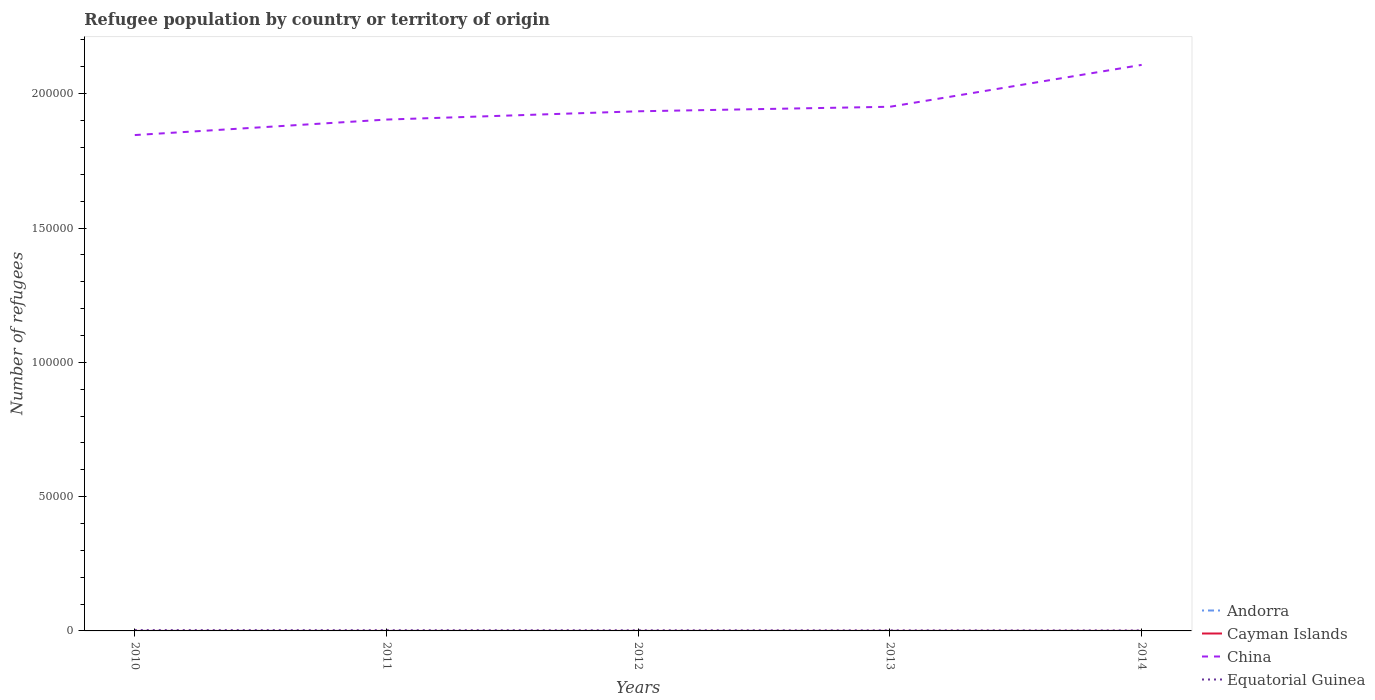How many different coloured lines are there?
Give a very brief answer. 4. Does the line corresponding to Equatorial Guinea intersect with the line corresponding to Cayman Islands?
Provide a succinct answer. No. Is the number of lines equal to the number of legend labels?
Provide a short and direct response. Yes. Across all years, what is the maximum number of refugees in China?
Give a very brief answer. 1.85e+05. In which year was the number of refugees in Cayman Islands maximum?
Your answer should be very brief. 2010. What is the total number of refugees in Andorra in the graph?
Provide a short and direct response. -1. What is the difference between the highest and the second highest number of refugees in Equatorial Guinea?
Provide a succinct answer. 131. What is the difference between the highest and the lowest number of refugees in Equatorial Guinea?
Keep it short and to the point. 2. Is the number of refugees in Andorra strictly greater than the number of refugees in China over the years?
Keep it short and to the point. Yes. How many lines are there?
Make the answer very short. 4. Are the values on the major ticks of Y-axis written in scientific E-notation?
Give a very brief answer. No. Does the graph contain any zero values?
Provide a succinct answer. No. Where does the legend appear in the graph?
Offer a terse response. Bottom right. What is the title of the graph?
Make the answer very short. Refugee population by country or territory of origin. What is the label or title of the X-axis?
Ensure brevity in your answer.  Years. What is the label or title of the Y-axis?
Provide a succinct answer. Number of refugees. What is the Number of refugees in Andorra in 2010?
Provide a succinct answer. 6. What is the Number of refugees of Cayman Islands in 2010?
Your response must be concise. 1. What is the Number of refugees of China in 2010?
Offer a very short reply. 1.85e+05. What is the Number of refugees of Equatorial Guinea in 2010?
Ensure brevity in your answer.  305. What is the Number of refugees in Andorra in 2011?
Ensure brevity in your answer.  6. What is the Number of refugees in Cayman Islands in 2011?
Offer a terse response. 1. What is the Number of refugees in China in 2011?
Make the answer very short. 1.90e+05. What is the Number of refugees of Equatorial Guinea in 2011?
Keep it short and to the point. 258. What is the Number of refugees of Andorra in 2012?
Your answer should be very brief. 7. What is the Number of refugees of China in 2012?
Make the answer very short. 1.93e+05. What is the Number of refugees in Equatorial Guinea in 2012?
Make the answer very short. 228. What is the Number of refugees of Cayman Islands in 2013?
Keep it short and to the point. 6. What is the Number of refugees of China in 2013?
Provide a succinct answer. 1.95e+05. What is the Number of refugees in Andorra in 2014?
Give a very brief answer. 7. What is the Number of refugees in China in 2014?
Make the answer very short. 2.11e+05. What is the Number of refugees of Equatorial Guinea in 2014?
Your answer should be compact. 174. Across all years, what is the maximum Number of refugees of China?
Ensure brevity in your answer.  2.11e+05. Across all years, what is the maximum Number of refugees of Equatorial Guinea?
Offer a terse response. 305. Across all years, what is the minimum Number of refugees in Andorra?
Provide a succinct answer. 5. Across all years, what is the minimum Number of refugees of China?
Provide a short and direct response. 1.85e+05. Across all years, what is the minimum Number of refugees of Equatorial Guinea?
Your answer should be compact. 174. What is the total Number of refugees of Andorra in the graph?
Offer a terse response. 31. What is the total Number of refugees in China in the graph?
Keep it short and to the point. 9.74e+05. What is the total Number of refugees in Equatorial Guinea in the graph?
Make the answer very short. 1165. What is the difference between the Number of refugees of Andorra in 2010 and that in 2011?
Keep it short and to the point. 0. What is the difference between the Number of refugees of Cayman Islands in 2010 and that in 2011?
Provide a succinct answer. 0. What is the difference between the Number of refugees of China in 2010 and that in 2011?
Your answer should be very brief. -5767. What is the difference between the Number of refugees in Andorra in 2010 and that in 2012?
Provide a short and direct response. -1. What is the difference between the Number of refugees in China in 2010 and that in 2012?
Your answer should be compact. -8851. What is the difference between the Number of refugees of Equatorial Guinea in 2010 and that in 2012?
Make the answer very short. 77. What is the difference between the Number of refugees in Cayman Islands in 2010 and that in 2013?
Make the answer very short. -5. What is the difference between the Number of refugees in China in 2010 and that in 2013?
Provide a succinct answer. -1.05e+04. What is the difference between the Number of refugees of Equatorial Guinea in 2010 and that in 2013?
Your answer should be compact. 105. What is the difference between the Number of refugees in Andorra in 2010 and that in 2014?
Your answer should be compact. -1. What is the difference between the Number of refugees of Cayman Islands in 2010 and that in 2014?
Your answer should be compact. -5. What is the difference between the Number of refugees in China in 2010 and that in 2014?
Your response must be concise. -2.61e+04. What is the difference between the Number of refugees of Equatorial Guinea in 2010 and that in 2014?
Make the answer very short. 131. What is the difference between the Number of refugees of Cayman Islands in 2011 and that in 2012?
Your response must be concise. 0. What is the difference between the Number of refugees in China in 2011 and that in 2012?
Make the answer very short. -3084. What is the difference between the Number of refugees in Andorra in 2011 and that in 2013?
Your answer should be compact. 1. What is the difference between the Number of refugees of China in 2011 and that in 2013?
Your response must be concise. -4768. What is the difference between the Number of refugees of Equatorial Guinea in 2011 and that in 2013?
Offer a very short reply. 58. What is the difference between the Number of refugees of Cayman Islands in 2011 and that in 2014?
Ensure brevity in your answer.  -5. What is the difference between the Number of refugees in China in 2011 and that in 2014?
Offer a very short reply. -2.04e+04. What is the difference between the Number of refugees in Cayman Islands in 2012 and that in 2013?
Offer a very short reply. -5. What is the difference between the Number of refugees in China in 2012 and that in 2013?
Your answer should be very brief. -1684. What is the difference between the Number of refugees of Equatorial Guinea in 2012 and that in 2013?
Your response must be concise. 28. What is the difference between the Number of refugees of China in 2012 and that in 2014?
Offer a terse response. -1.73e+04. What is the difference between the Number of refugees of Equatorial Guinea in 2012 and that in 2014?
Provide a succinct answer. 54. What is the difference between the Number of refugees in Andorra in 2013 and that in 2014?
Your answer should be very brief. -2. What is the difference between the Number of refugees in China in 2013 and that in 2014?
Keep it short and to the point. -1.56e+04. What is the difference between the Number of refugees of Andorra in 2010 and the Number of refugees of China in 2011?
Give a very brief answer. -1.90e+05. What is the difference between the Number of refugees in Andorra in 2010 and the Number of refugees in Equatorial Guinea in 2011?
Offer a terse response. -252. What is the difference between the Number of refugees in Cayman Islands in 2010 and the Number of refugees in China in 2011?
Provide a short and direct response. -1.90e+05. What is the difference between the Number of refugees of Cayman Islands in 2010 and the Number of refugees of Equatorial Guinea in 2011?
Your answer should be compact. -257. What is the difference between the Number of refugees of China in 2010 and the Number of refugees of Equatorial Guinea in 2011?
Your response must be concise. 1.84e+05. What is the difference between the Number of refugees in Andorra in 2010 and the Number of refugees in China in 2012?
Offer a terse response. -1.93e+05. What is the difference between the Number of refugees of Andorra in 2010 and the Number of refugees of Equatorial Guinea in 2012?
Ensure brevity in your answer.  -222. What is the difference between the Number of refugees in Cayman Islands in 2010 and the Number of refugees in China in 2012?
Provide a short and direct response. -1.93e+05. What is the difference between the Number of refugees of Cayman Islands in 2010 and the Number of refugees of Equatorial Guinea in 2012?
Make the answer very short. -227. What is the difference between the Number of refugees in China in 2010 and the Number of refugees in Equatorial Guinea in 2012?
Keep it short and to the point. 1.84e+05. What is the difference between the Number of refugees of Andorra in 2010 and the Number of refugees of China in 2013?
Offer a terse response. -1.95e+05. What is the difference between the Number of refugees of Andorra in 2010 and the Number of refugees of Equatorial Guinea in 2013?
Make the answer very short. -194. What is the difference between the Number of refugees in Cayman Islands in 2010 and the Number of refugees in China in 2013?
Provide a short and direct response. -1.95e+05. What is the difference between the Number of refugees of Cayman Islands in 2010 and the Number of refugees of Equatorial Guinea in 2013?
Offer a very short reply. -199. What is the difference between the Number of refugees in China in 2010 and the Number of refugees in Equatorial Guinea in 2013?
Keep it short and to the point. 1.84e+05. What is the difference between the Number of refugees in Andorra in 2010 and the Number of refugees in Cayman Islands in 2014?
Give a very brief answer. 0. What is the difference between the Number of refugees in Andorra in 2010 and the Number of refugees in China in 2014?
Your response must be concise. -2.11e+05. What is the difference between the Number of refugees in Andorra in 2010 and the Number of refugees in Equatorial Guinea in 2014?
Keep it short and to the point. -168. What is the difference between the Number of refugees of Cayman Islands in 2010 and the Number of refugees of China in 2014?
Your response must be concise. -2.11e+05. What is the difference between the Number of refugees of Cayman Islands in 2010 and the Number of refugees of Equatorial Guinea in 2014?
Your response must be concise. -173. What is the difference between the Number of refugees of China in 2010 and the Number of refugees of Equatorial Guinea in 2014?
Provide a short and direct response. 1.84e+05. What is the difference between the Number of refugees of Andorra in 2011 and the Number of refugees of China in 2012?
Your response must be concise. -1.93e+05. What is the difference between the Number of refugees in Andorra in 2011 and the Number of refugees in Equatorial Guinea in 2012?
Make the answer very short. -222. What is the difference between the Number of refugees in Cayman Islands in 2011 and the Number of refugees in China in 2012?
Give a very brief answer. -1.93e+05. What is the difference between the Number of refugees in Cayman Islands in 2011 and the Number of refugees in Equatorial Guinea in 2012?
Offer a very short reply. -227. What is the difference between the Number of refugees of China in 2011 and the Number of refugees of Equatorial Guinea in 2012?
Make the answer very short. 1.90e+05. What is the difference between the Number of refugees of Andorra in 2011 and the Number of refugees of China in 2013?
Keep it short and to the point. -1.95e+05. What is the difference between the Number of refugees of Andorra in 2011 and the Number of refugees of Equatorial Guinea in 2013?
Offer a very short reply. -194. What is the difference between the Number of refugees of Cayman Islands in 2011 and the Number of refugees of China in 2013?
Your answer should be very brief. -1.95e+05. What is the difference between the Number of refugees of Cayman Islands in 2011 and the Number of refugees of Equatorial Guinea in 2013?
Offer a very short reply. -199. What is the difference between the Number of refugees in China in 2011 and the Number of refugees in Equatorial Guinea in 2013?
Offer a very short reply. 1.90e+05. What is the difference between the Number of refugees in Andorra in 2011 and the Number of refugees in China in 2014?
Ensure brevity in your answer.  -2.11e+05. What is the difference between the Number of refugees of Andorra in 2011 and the Number of refugees of Equatorial Guinea in 2014?
Ensure brevity in your answer.  -168. What is the difference between the Number of refugees in Cayman Islands in 2011 and the Number of refugees in China in 2014?
Give a very brief answer. -2.11e+05. What is the difference between the Number of refugees in Cayman Islands in 2011 and the Number of refugees in Equatorial Guinea in 2014?
Your answer should be very brief. -173. What is the difference between the Number of refugees in China in 2011 and the Number of refugees in Equatorial Guinea in 2014?
Ensure brevity in your answer.  1.90e+05. What is the difference between the Number of refugees of Andorra in 2012 and the Number of refugees of China in 2013?
Ensure brevity in your answer.  -1.95e+05. What is the difference between the Number of refugees of Andorra in 2012 and the Number of refugees of Equatorial Guinea in 2013?
Provide a succinct answer. -193. What is the difference between the Number of refugees of Cayman Islands in 2012 and the Number of refugees of China in 2013?
Provide a succinct answer. -1.95e+05. What is the difference between the Number of refugees in Cayman Islands in 2012 and the Number of refugees in Equatorial Guinea in 2013?
Offer a very short reply. -199. What is the difference between the Number of refugees of China in 2012 and the Number of refugees of Equatorial Guinea in 2013?
Ensure brevity in your answer.  1.93e+05. What is the difference between the Number of refugees of Andorra in 2012 and the Number of refugees of Cayman Islands in 2014?
Offer a terse response. 1. What is the difference between the Number of refugees in Andorra in 2012 and the Number of refugees in China in 2014?
Give a very brief answer. -2.11e+05. What is the difference between the Number of refugees of Andorra in 2012 and the Number of refugees of Equatorial Guinea in 2014?
Offer a terse response. -167. What is the difference between the Number of refugees of Cayman Islands in 2012 and the Number of refugees of China in 2014?
Your answer should be very brief. -2.11e+05. What is the difference between the Number of refugees in Cayman Islands in 2012 and the Number of refugees in Equatorial Guinea in 2014?
Offer a terse response. -173. What is the difference between the Number of refugees of China in 2012 and the Number of refugees of Equatorial Guinea in 2014?
Ensure brevity in your answer.  1.93e+05. What is the difference between the Number of refugees of Andorra in 2013 and the Number of refugees of Cayman Islands in 2014?
Keep it short and to the point. -1. What is the difference between the Number of refugees in Andorra in 2013 and the Number of refugees in China in 2014?
Your answer should be very brief. -2.11e+05. What is the difference between the Number of refugees of Andorra in 2013 and the Number of refugees of Equatorial Guinea in 2014?
Your answer should be very brief. -169. What is the difference between the Number of refugees of Cayman Islands in 2013 and the Number of refugees of China in 2014?
Your answer should be very brief. -2.11e+05. What is the difference between the Number of refugees in Cayman Islands in 2013 and the Number of refugees in Equatorial Guinea in 2014?
Ensure brevity in your answer.  -168. What is the difference between the Number of refugees of China in 2013 and the Number of refugees of Equatorial Guinea in 2014?
Give a very brief answer. 1.95e+05. What is the average Number of refugees of Andorra per year?
Your answer should be compact. 6.2. What is the average Number of refugees of Cayman Islands per year?
Provide a succinct answer. 3. What is the average Number of refugees of China per year?
Ensure brevity in your answer.  1.95e+05. What is the average Number of refugees of Equatorial Guinea per year?
Your response must be concise. 233. In the year 2010, what is the difference between the Number of refugees in Andorra and Number of refugees in China?
Ensure brevity in your answer.  -1.85e+05. In the year 2010, what is the difference between the Number of refugees of Andorra and Number of refugees of Equatorial Guinea?
Provide a short and direct response. -299. In the year 2010, what is the difference between the Number of refugees of Cayman Islands and Number of refugees of China?
Offer a very short reply. -1.85e+05. In the year 2010, what is the difference between the Number of refugees of Cayman Islands and Number of refugees of Equatorial Guinea?
Your response must be concise. -304. In the year 2010, what is the difference between the Number of refugees in China and Number of refugees in Equatorial Guinea?
Ensure brevity in your answer.  1.84e+05. In the year 2011, what is the difference between the Number of refugees in Andorra and Number of refugees in Cayman Islands?
Your answer should be very brief. 5. In the year 2011, what is the difference between the Number of refugees in Andorra and Number of refugees in China?
Keep it short and to the point. -1.90e+05. In the year 2011, what is the difference between the Number of refugees in Andorra and Number of refugees in Equatorial Guinea?
Give a very brief answer. -252. In the year 2011, what is the difference between the Number of refugees of Cayman Islands and Number of refugees of China?
Your response must be concise. -1.90e+05. In the year 2011, what is the difference between the Number of refugees in Cayman Islands and Number of refugees in Equatorial Guinea?
Your answer should be compact. -257. In the year 2011, what is the difference between the Number of refugees in China and Number of refugees in Equatorial Guinea?
Provide a short and direct response. 1.90e+05. In the year 2012, what is the difference between the Number of refugees in Andorra and Number of refugees in Cayman Islands?
Your answer should be compact. 6. In the year 2012, what is the difference between the Number of refugees in Andorra and Number of refugees in China?
Your answer should be compact. -1.93e+05. In the year 2012, what is the difference between the Number of refugees of Andorra and Number of refugees of Equatorial Guinea?
Keep it short and to the point. -221. In the year 2012, what is the difference between the Number of refugees in Cayman Islands and Number of refugees in China?
Your answer should be very brief. -1.93e+05. In the year 2012, what is the difference between the Number of refugees in Cayman Islands and Number of refugees in Equatorial Guinea?
Offer a terse response. -227. In the year 2012, what is the difference between the Number of refugees of China and Number of refugees of Equatorial Guinea?
Your answer should be very brief. 1.93e+05. In the year 2013, what is the difference between the Number of refugees of Andorra and Number of refugees of China?
Provide a succinct answer. -1.95e+05. In the year 2013, what is the difference between the Number of refugees in Andorra and Number of refugees in Equatorial Guinea?
Offer a terse response. -195. In the year 2013, what is the difference between the Number of refugees of Cayman Islands and Number of refugees of China?
Make the answer very short. -1.95e+05. In the year 2013, what is the difference between the Number of refugees in Cayman Islands and Number of refugees in Equatorial Guinea?
Provide a succinct answer. -194. In the year 2013, what is the difference between the Number of refugees in China and Number of refugees in Equatorial Guinea?
Ensure brevity in your answer.  1.95e+05. In the year 2014, what is the difference between the Number of refugees in Andorra and Number of refugees in Cayman Islands?
Offer a terse response. 1. In the year 2014, what is the difference between the Number of refugees of Andorra and Number of refugees of China?
Your response must be concise. -2.11e+05. In the year 2014, what is the difference between the Number of refugees in Andorra and Number of refugees in Equatorial Guinea?
Provide a short and direct response. -167. In the year 2014, what is the difference between the Number of refugees of Cayman Islands and Number of refugees of China?
Ensure brevity in your answer.  -2.11e+05. In the year 2014, what is the difference between the Number of refugees of Cayman Islands and Number of refugees of Equatorial Guinea?
Offer a terse response. -168. In the year 2014, what is the difference between the Number of refugees in China and Number of refugees in Equatorial Guinea?
Offer a very short reply. 2.11e+05. What is the ratio of the Number of refugees in Cayman Islands in 2010 to that in 2011?
Your response must be concise. 1. What is the ratio of the Number of refugees of China in 2010 to that in 2011?
Provide a short and direct response. 0.97. What is the ratio of the Number of refugees of Equatorial Guinea in 2010 to that in 2011?
Make the answer very short. 1.18. What is the ratio of the Number of refugees of Andorra in 2010 to that in 2012?
Your answer should be compact. 0.86. What is the ratio of the Number of refugees in China in 2010 to that in 2012?
Your answer should be compact. 0.95. What is the ratio of the Number of refugees in Equatorial Guinea in 2010 to that in 2012?
Your answer should be compact. 1.34. What is the ratio of the Number of refugees in Cayman Islands in 2010 to that in 2013?
Ensure brevity in your answer.  0.17. What is the ratio of the Number of refugees in China in 2010 to that in 2013?
Provide a short and direct response. 0.95. What is the ratio of the Number of refugees in Equatorial Guinea in 2010 to that in 2013?
Give a very brief answer. 1.52. What is the ratio of the Number of refugees of Andorra in 2010 to that in 2014?
Keep it short and to the point. 0.86. What is the ratio of the Number of refugees in China in 2010 to that in 2014?
Make the answer very short. 0.88. What is the ratio of the Number of refugees of Equatorial Guinea in 2010 to that in 2014?
Your answer should be very brief. 1.75. What is the ratio of the Number of refugees in Andorra in 2011 to that in 2012?
Provide a succinct answer. 0.86. What is the ratio of the Number of refugees in Cayman Islands in 2011 to that in 2012?
Offer a terse response. 1. What is the ratio of the Number of refugees in China in 2011 to that in 2012?
Make the answer very short. 0.98. What is the ratio of the Number of refugees of Equatorial Guinea in 2011 to that in 2012?
Offer a terse response. 1.13. What is the ratio of the Number of refugees of Andorra in 2011 to that in 2013?
Make the answer very short. 1.2. What is the ratio of the Number of refugees of China in 2011 to that in 2013?
Offer a very short reply. 0.98. What is the ratio of the Number of refugees of Equatorial Guinea in 2011 to that in 2013?
Provide a succinct answer. 1.29. What is the ratio of the Number of refugees in Andorra in 2011 to that in 2014?
Your response must be concise. 0.86. What is the ratio of the Number of refugees of China in 2011 to that in 2014?
Your answer should be compact. 0.9. What is the ratio of the Number of refugees of Equatorial Guinea in 2011 to that in 2014?
Provide a succinct answer. 1.48. What is the ratio of the Number of refugees of Cayman Islands in 2012 to that in 2013?
Ensure brevity in your answer.  0.17. What is the ratio of the Number of refugees of China in 2012 to that in 2013?
Provide a succinct answer. 0.99. What is the ratio of the Number of refugees in Equatorial Guinea in 2012 to that in 2013?
Make the answer very short. 1.14. What is the ratio of the Number of refugees of Andorra in 2012 to that in 2014?
Offer a terse response. 1. What is the ratio of the Number of refugees of China in 2012 to that in 2014?
Your answer should be compact. 0.92. What is the ratio of the Number of refugees in Equatorial Guinea in 2012 to that in 2014?
Keep it short and to the point. 1.31. What is the ratio of the Number of refugees of China in 2013 to that in 2014?
Ensure brevity in your answer.  0.93. What is the ratio of the Number of refugees of Equatorial Guinea in 2013 to that in 2014?
Give a very brief answer. 1.15. What is the difference between the highest and the second highest Number of refugees of China?
Provide a short and direct response. 1.56e+04. What is the difference between the highest and the lowest Number of refugees in Andorra?
Give a very brief answer. 2. What is the difference between the highest and the lowest Number of refugees of Cayman Islands?
Offer a terse response. 5. What is the difference between the highest and the lowest Number of refugees in China?
Make the answer very short. 2.61e+04. What is the difference between the highest and the lowest Number of refugees in Equatorial Guinea?
Your answer should be very brief. 131. 